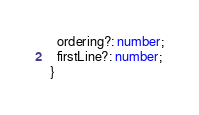<code> <loc_0><loc_0><loc_500><loc_500><_TypeScript_>  ordering?: number;
  firstLine?: number;
}
</code> 